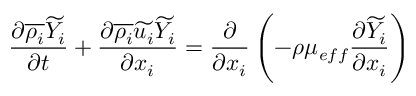Convert formula to latex. <formula><loc_0><loc_0><loc_500><loc_500>\frac { \partial \overline { { \rho _ { i } } } \widetilde { Y _ { i } } } { \partial t } + \frac { \partial \overline { { \rho _ { i } } } \widetilde { u _ { i } } \widetilde { Y _ { i } } } { \partial x _ { i } } = \frac { \partial } { \partial { x _ { i } } } \left ( - \rho \mu _ { e f f } \frac { \partial \widetilde { Y _ { i } } } { \partial { x _ { i } } } \right )</formula> 